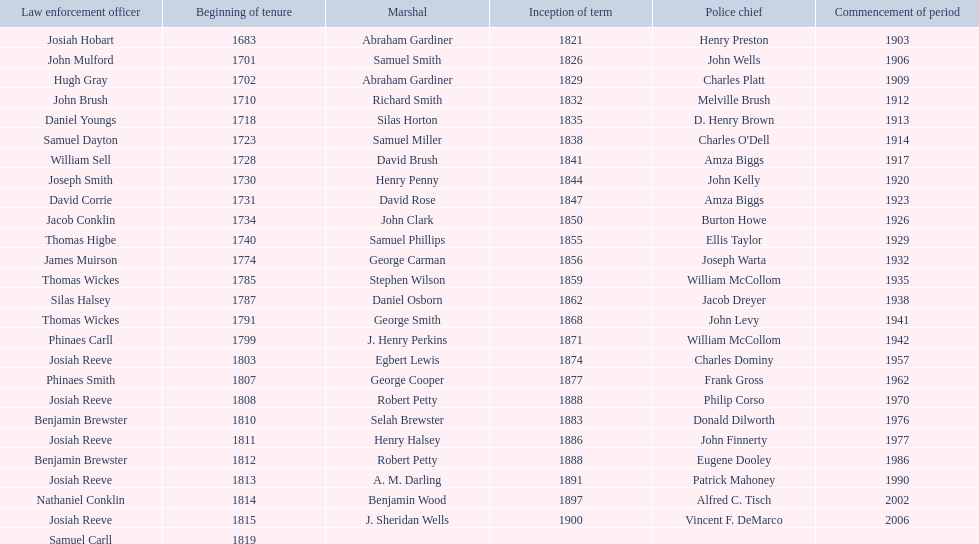How sheriffs has suffolk county had in total? 76. 